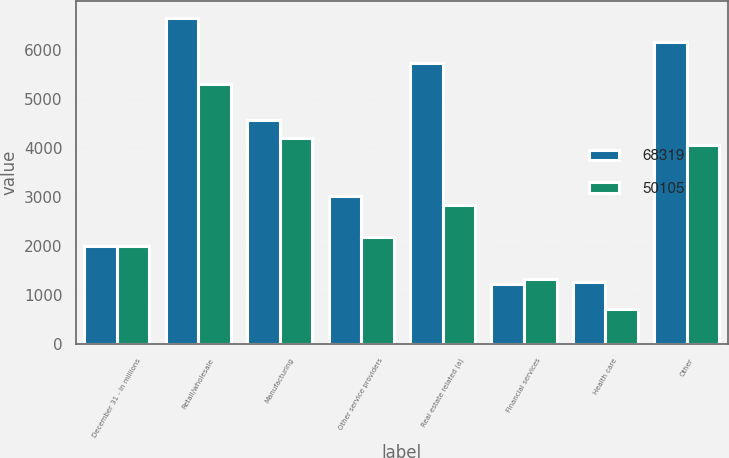Convert chart. <chart><loc_0><loc_0><loc_500><loc_500><stacked_bar_chart><ecel><fcel>December 31 - in millions<fcel>Retail/wholesale<fcel>Manufacturing<fcel>Other service providers<fcel>Real estate related (a)<fcel>Financial services<fcel>Health care<fcel>Other<nl><fcel>68319<fcel>2007<fcel>6653<fcel>4563<fcel>3014<fcel>5730<fcel>1226<fcel>1260<fcel>6161<nl><fcel>50105<fcel>2006<fcel>5301<fcel>4189<fcel>2186<fcel>2825<fcel>1324<fcel>707<fcel>4052<nl></chart> 